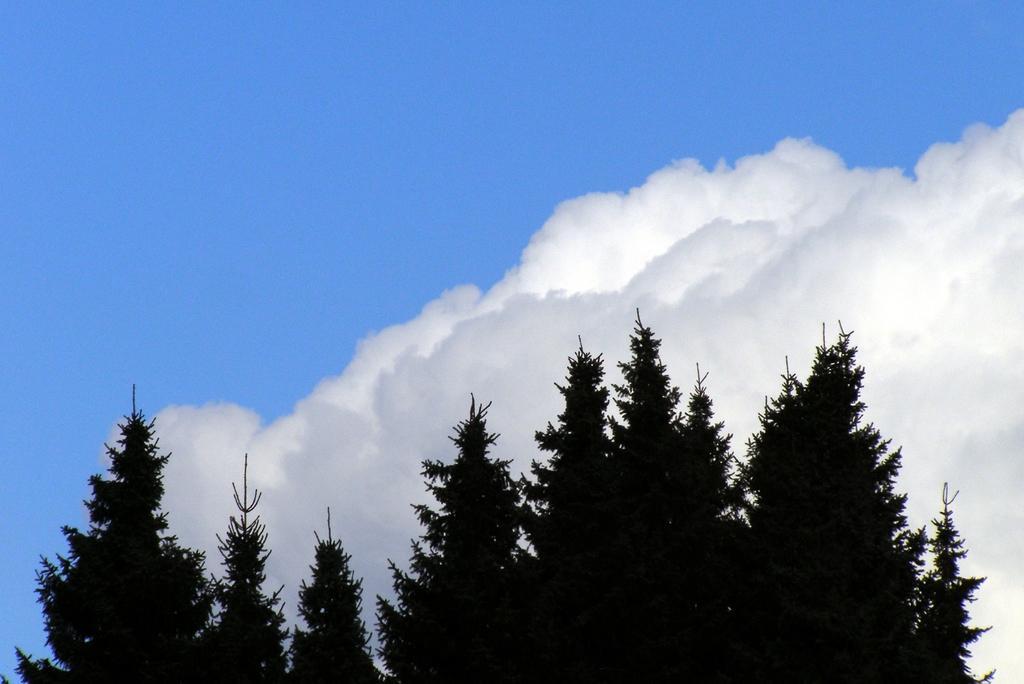Please provide a concise description of this image. At the bottom of the image there are some trees. At the top of the image there are some clouds in the sky. 